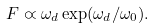<formula> <loc_0><loc_0><loc_500><loc_500>F \varpropto \omega _ { d } \exp ( \omega _ { d } / \omega _ { 0 } ) .</formula> 